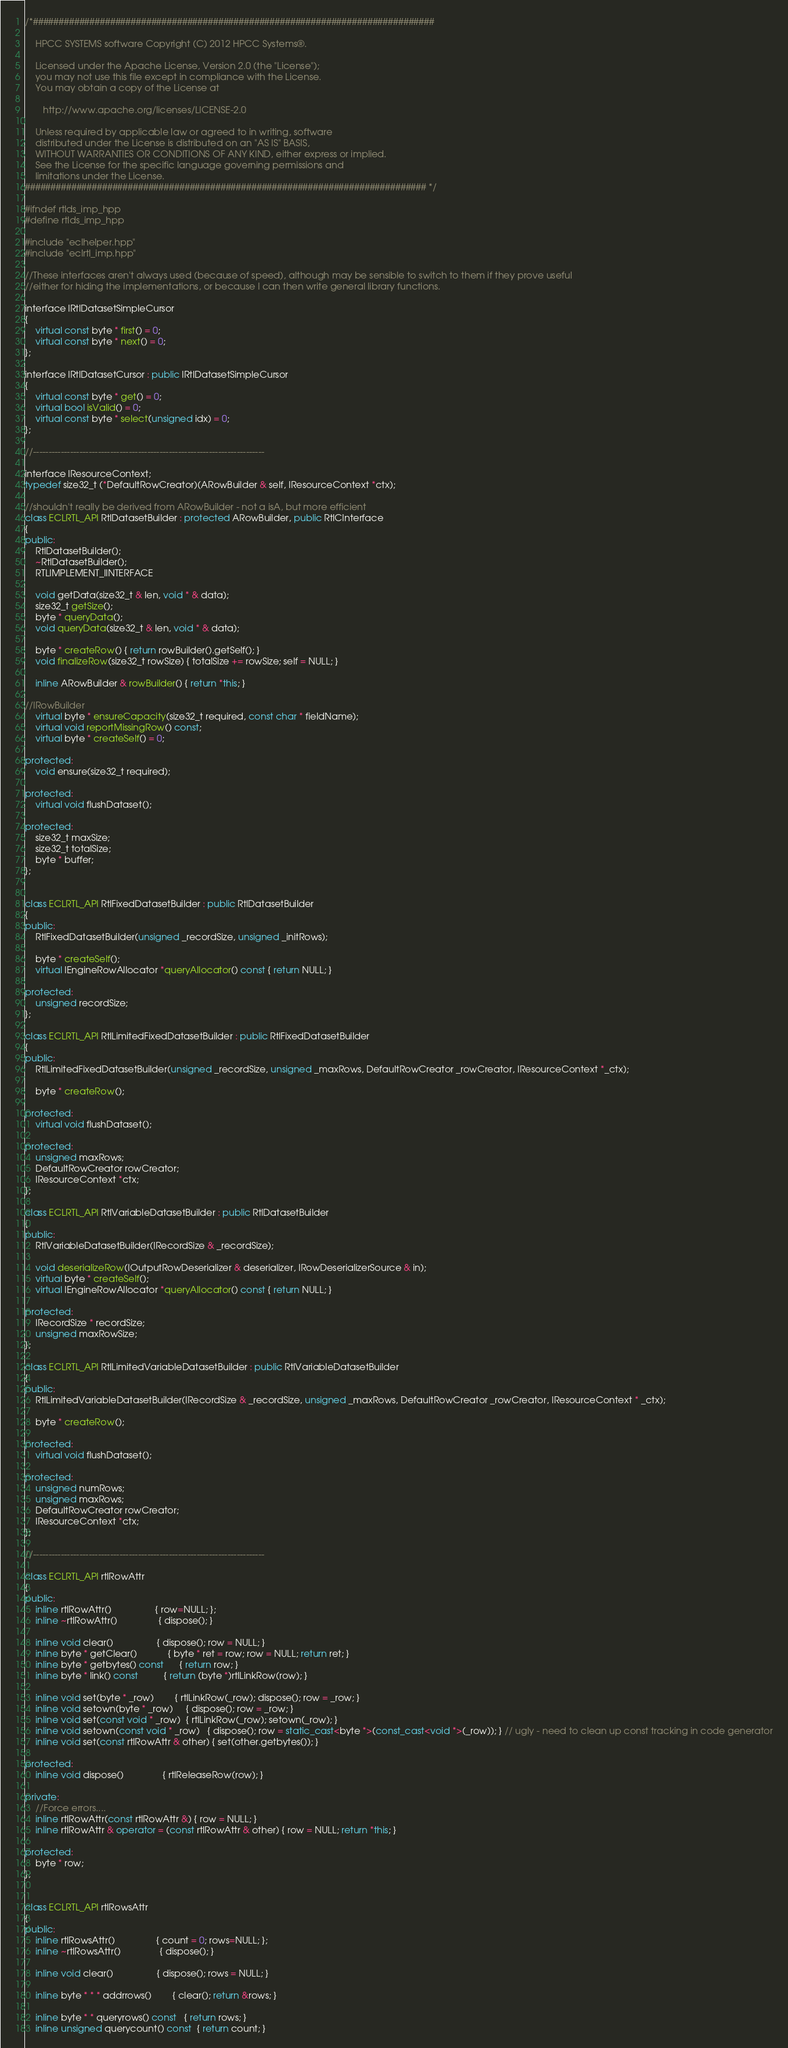<code> <loc_0><loc_0><loc_500><loc_500><_C++_>/*##############################################################################

    HPCC SYSTEMS software Copyright (C) 2012 HPCC Systems®.

    Licensed under the Apache License, Version 2.0 (the "License");
    you may not use this file except in compliance with the License.
    You may obtain a copy of the License at

       http://www.apache.org/licenses/LICENSE-2.0

    Unless required by applicable law or agreed to in writing, software
    distributed under the License is distributed on an "AS IS" BASIS,
    WITHOUT WARRANTIES OR CONDITIONS OF ANY KIND, either express or implied.
    See the License for the specific language governing permissions and
    limitations under the License.
############################################################################## */

#ifndef rtlds_imp_hpp
#define rtlds_imp_hpp

#include "eclhelper.hpp"
#include "eclrtl_imp.hpp"

//These interfaces aren't always used (because of speed), although may be sensible to switch to them if they prove useful
//either for hiding the implementations, or because I can then write general library functions.

interface IRtlDatasetSimpleCursor
{
    virtual const byte * first() = 0;
    virtual const byte * next() = 0;
};

interface IRtlDatasetCursor : public IRtlDatasetSimpleCursor
{
    virtual const byte * get() = 0;
    virtual bool isValid() = 0;
    virtual const byte * select(unsigned idx) = 0;
};

//---------------------------------------------------------------------------

interface IResourceContext;
typedef size32_t (*DefaultRowCreator)(ARowBuilder & self, IResourceContext *ctx);

//shouldn't really be derived from ARowBuilder - not a isA, but more efficient
class ECLRTL_API RtlDatasetBuilder : protected ARowBuilder, public RtlCInterface
{
public:
    RtlDatasetBuilder();
    ~RtlDatasetBuilder();
    RTLIMPLEMENT_IINTERFACE

    void getData(size32_t & len, void * & data);
    size32_t getSize();
    byte * queryData();
    void queryData(size32_t & len, void * & data);

    byte * createRow() { return rowBuilder().getSelf(); }
    void finalizeRow(size32_t rowSize) { totalSize += rowSize; self = NULL; }

    inline ARowBuilder & rowBuilder() { return *this; }

//IRowBuilder
    virtual byte * ensureCapacity(size32_t required, const char * fieldName);
    virtual void reportMissingRow() const;
    virtual byte * createSelf() = 0;

protected:
    void ensure(size32_t required);

protected:
    virtual void flushDataset();

protected:
    size32_t maxSize;
    size32_t totalSize;
    byte * buffer;
};


class ECLRTL_API RtlFixedDatasetBuilder : public RtlDatasetBuilder
{
public:
    RtlFixedDatasetBuilder(unsigned _recordSize, unsigned _initRows);

    byte * createSelf();
    virtual IEngineRowAllocator *queryAllocator() const { return NULL; }

protected:
    unsigned recordSize;
};

class ECLRTL_API RtlLimitedFixedDatasetBuilder : public RtlFixedDatasetBuilder
{
public: 
    RtlLimitedFixedDatasetBuilder(unsigned _recordSize, unsigned _maxRows, DefaultRowCreator _rowCreator, IResourceContext *_ctx);

    byte * createRow();

protected:
    virtual void flushDataset();

protected:
    unsigned maxRows;
    DefaultRowCreator rowCreator;
    IResourceContext *ctx;
};

class ECLRTL_API RtlVariableDatasetBuilder : public RtlDatasetBuilder
{
public:
    RtlVariableDatasetBuilder(IRecordSize & _recordSize);

    void deserializeRow(IOutputRowDeserializer & deserializer, IRowDeserializerSource & in);
    virtual byte * createSelf();
    virtual IEngineRowAllocator *queryAllocator() const { return NULL; }

protected:
    IRecordSize * recordSize;
    unsigned maxRowSize;
};

class ECLRTL_API RtlLimitedVariableDatasetBuilder : public RtlVariableDatasetBuilder
{
public:
    RtlLimitedVariableDatasetBuilder(IRecordSize & _recordSize, unsigned _maxRows, DefaultRowCreator _rowCreator, IResourceContext * _ctx);

    byte * createRow();

protected:
    virtual void flushDataset();

protected:
    unsigned numRows;
    unsigned maxRows;
    DefaultRowCreator rowCreator;
    IResourceContext *ctx;
};

//---------------------------------------------------------------------------

class ECLRTL_API rtlRowAttr
{
public:
    inline rtlRowAttr()                 { row=NULL; };
    inline ~rtlRowAttr()                { dispose(); }

    inline void clear()                 { dispose(); row = NULL; }
    inline byte * getClear()            { byte * ret = row; row = NULL; return ret; }
    inline byte * getbytes() const      { return row; }
    inline byte * link() const          { return (byte *)rtlLinkRow(row); }

    inline void set(byte * _row)        { rtlLinkRow(_row); dispose(); row = _row; }
    inline void setown(byte * _row)     { dispose(); row = _row; }
    inline void set(const void * _row)  { rtlLinkRow(_row); setown(_row); }
    inline void setown(const void * _row)   { dispose(); row = static_cast<byte *>(const_cast<void *>(_row)); } // ugly - need to clean up const tracking in code generator
    inline void set(const rtlRowAttr & other) { set(other.getbytes()); }

protected:
    inline void dispose()               { rtlReleaseRow(row); }

private:
    //Force errors....
    inline rtlRowAttr(const rtlRowAttr &) { row = NULL; }
    inline rtlRowAttr & operator = (const rtlRowAttr & other) { row = NULL; return *this; }

protected:
    byte * row;
};


class ECLRTL_API rtlRowsAttr
{
public:
    inline rtlRowsAttr()                { count = 0; rows=NULL; };
    inline ~rtlRowsAttr()               { dispose(); }

    inline void clear()                 { dispose(); rows = NULL; }

    inline byte * * * addrrows()        { clear(); return &rows; }

    inline byte * * queryrows() const   { return rows; }
    inline unsigned querycount() const  { return count; }
</code> 